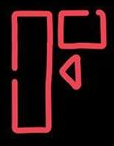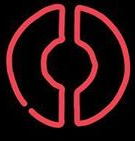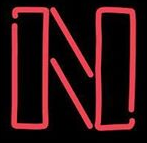Identify the words shown in these images in order, separated by a semicolon. F; O; N 